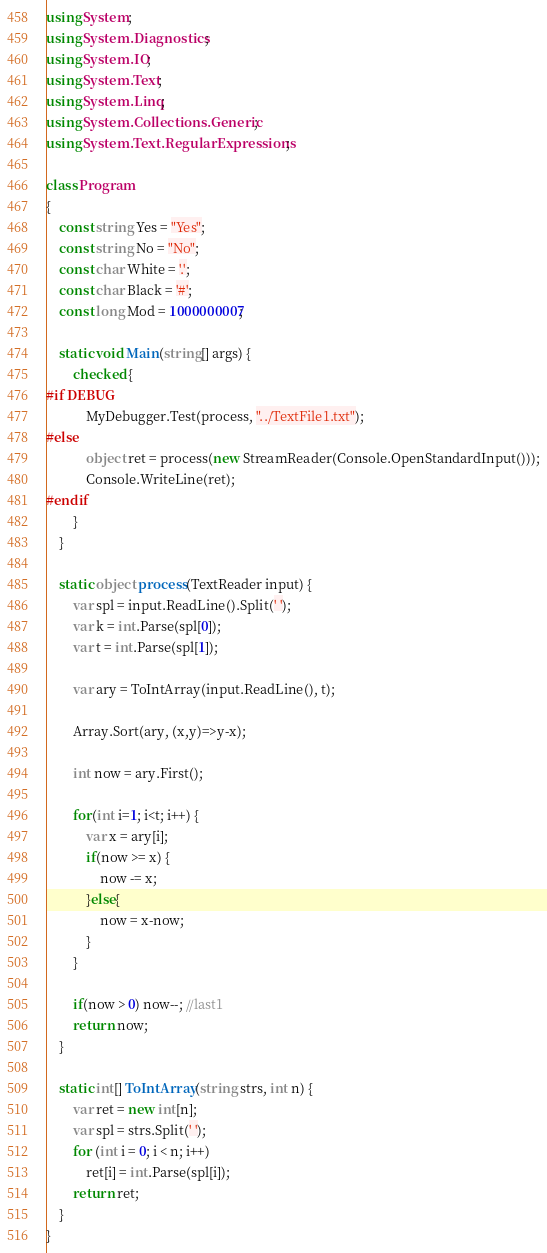Convert code to text. <code><loc_0><loc_0><loc_500><loc_500><_C#_>using System;
using System.Diagnostics;
using System.IO;
using System.Text;
using System.Linq;
using System.Collections.Generic;
using System.Text.RegularExpressions;

class Program
{
    const string Yes = "Yes";
    const string No = "No";
    const char White = '.';
    const char Black = '#';
    const long Mod = 1000000007;

    static void Main(string[] args) {
        checked {
#if DEBUG
            MyDebugger.Test(process, "../TextFile1.txt");
#else
            object ret = process(new StreamReader(Console.OpenStandardInput()));
            Console.WriteLine(ret);
#endif
        }
    }

    static object process(TextReader input) {
        var spl = input.ReadLine().Split(' ');
        var k = int.Parse(spl[0]);
        var t = int.Parse(spl[1]);

        var ary = ToIntArray(input.ReadLine(), t);

        Array.Sort(ary, (x,y)=>y-x);

        int now = ary.First();

        for(int i=1; i<t; i++) {
            var x = ary[i];
            if(now >= x) {
                now -= x;
            }else{
                now = x-now;
            }
        }

        if(now > 0) now--; //last1
        return now;
    }

    static int[] ToIntArray(string strs, int n) {
        var ret = new int[n];
        var spl = strs.Split(' ');
        for (int i = 0; i < n; i++)
            ret[i] = int.Parse(spl[i]);
        return ret;
    }
}
</code> 